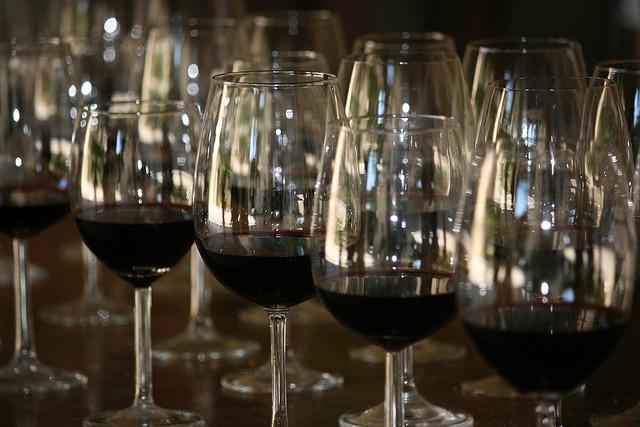Are the wine glasses empty?
Keep it brief. No. How many glasses are in the table?
Give a very brief answer. 15. What is in the glasses?
Keep it brief. Wine. What type of glasses are these?
Be succinct. Wine. 